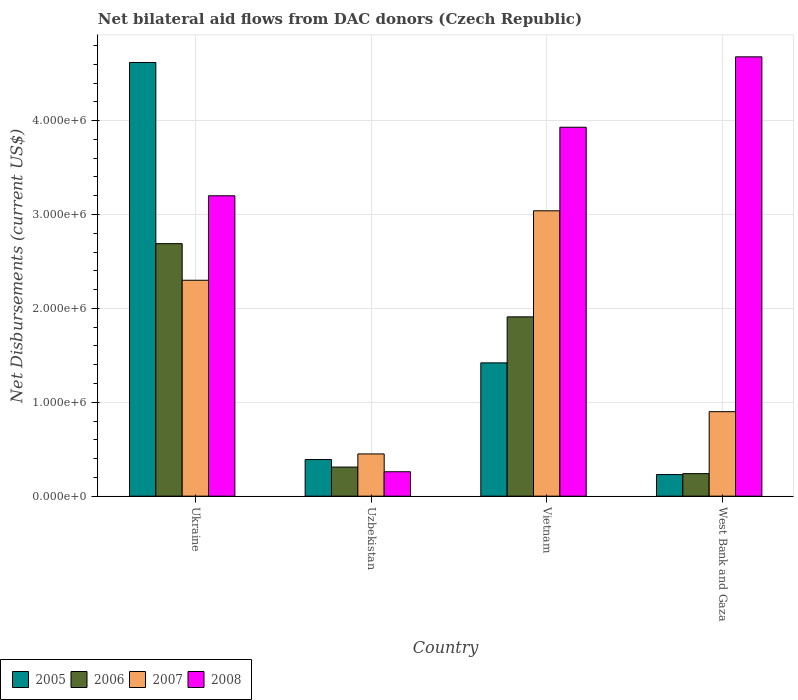How many groups of bars are there?
Your response must be concise. 4. Are the number of bars per tick equal to the number of legend labels?
Your answer should be compact. Yes. Are the number of bars on each tick of the X-axis equal?
Your response must be concise. Yes. What is the label of the 2nd group of bars from the left?
Keep it short and to the point. Uzbekistan. What is the net bilateral aid flows in 2006 in Uzbekistan?
Offer a very short reply. 3.10e+05. Across all countries, what is the maximum net bilateral aid flows in 2007?
Offer a terse response. 3.04e+06. Across all countries, what is the minimum net bilateral aid flows in 2008?
Keep it short and to the point. 2.60e+05. In which country was the net bilateral aid flows in 2008 maximum?
Provide a short and direct response. West Bank and Gaza. In which country was the net bilateral aid flows in 2007 minimum?
Make the answer very short. Uzbekistan. What is the total net bilateral aid flows in 2007 in the graph?
Give a very brief answer. 6.69e+06. What is the difference between the net bilateral aid flows in 2005 in Ukraine and that in Vietnam?
Keep it short and to the point. 3.20e+06. What is the difference between the net bilateral aid flows in 2007 in Vietnam and the net bilateral aid flows in 2006 in Uzbekistan?
Give a very brief answer. 2.73e+06. What is the average net bilateral aid flows in 2006 per country?
Keep it short and to the point. 1.29e+06. What is the difference between the net bilateral aid flows of/in 2007 and net bilateral aid flows of/in 2006 in Ukraine?
Make the answer very short. -3.90e+05. In how many countries, is the net bilateral aid flows in 2008 greater than 3000000 US$?
Provide a short and direct response. 3. What is the ratio of the net bilateral aid flows in 2006 in Uzbekistan to that in Vietnam?
Ensure brevity in your answer.  0.16. Is the net bilateral aid flows in 2005 in Ukraine less than that in West Bank and Gaza?
Your response must be concise. No. What is the difference between the highest and the second highest net bilateral aid flows in 2008?
Your answer should be very brief. 1.48e+06. What is the difference between the highest and the lowest net bilateral aid flows in 2005?
Your answer should be compact. 4.39e+06. In how many countries, is the net bilateral aid flows in 2007 greater than the average net bilateral aid flows in 2007 taken over all countries?
Provide a short and direct response. 2. Is it the case that in every country, the sum of the net bilateral aid flows in 2005 and net bilateral aid flows in 2008 is greater than the sum of net bilateral aid flows in 2007 and net bilateral aid flows in 2006?
Your answer should be very brief. No. What does the 3rd bar from the left in Uzbekistan represents?
Offer a terse response. 2007. Are all the bars in the graph horizontal?
Provide a short and direct response. No. How many countries are there in the graph?
Offer a terse response. 4. What is the difference between two consecutive major ticks on the Y-axis?
Provide a short and direct response. 1.00e+06. Does the graph contain any zero values?
Make the answer very short. No. Does the graph contain grids?
Provide a succinct answer. Yes. Where does the legend appear in the graph?
Give a very brief answer. Bottom left. How are the legend labels stacked?
Offer a very short reply. Horizontal. What is the title of the graph?
Your response must be concise. Net bilateral aid flows from DAC donors (Czech Republic). What is the label or title of the Y-axis?
Keep it short and to the point. Net Disbursements (current US$). What is the Net Disbursements (current US$) in 2005 in Ukraine?
Ensure brevity in your answer.  4.62e+06. What is the Net Disbursements (current US$) of 2006 in Ukraine?
Keep it short and to the point. 2.69e+06. What is the Net Disbursements (current US$) in 2007 in Ukraine?
Offer a very short reply. 2.30e+06. What is the Net Disbursements (current US$) in 2008 in Ukraine?
Keep it short and to the point. 3.20e+06. What is the Net Disbursements (current US$) of 2006 in Uzbekistan?
Your response must be concise. 3.10e+05. What is the Net Disbursements (current US$) in 2005 in Vietnam?
Your response must be concise. 1.42e+06. What is the Net Disbursements (current US$) of 2006 in Vietnam?
Offer a very short reply. 1.91e+06. What is the Net Disbursements (current US$) in 2007 in Vietnam?
Provide a short and direct response. 3.04e+06. What is the Net Disbursements (current US$) in 2008 in Vietnam?
Your answer should be compact. 3.93e+06. What is the Net Disbursements (current US$) in 2008 in West Bank and Gaza?
Offer a very short reply. 4.68e+06. Across all countries, what is the maximum Net Disbursements (current US$) in 2005?
Offer a terse response. 4.62e+06. Across all countries, what is the maximum Net Disbursements (current US$) of 2006?
Your response must be concise. 2.69e+06. Across all countries, what is the maximum Net Disbursements (current US$) of 2007?
Provide a succinct answer. 3.04e+06. Across all countries, what is the maximum Net Disbursements (current US$) of 2008?
Offer a very short reply. 4.68e+06. Across all countries, what is the minimum Net Disbursements (current US$) in 2005?
Provide a short and direct response. 2.30e+05. What is the total Net Disbursements (current US$) in 2005 in the graph?
Provide a succinct answer. 6.66e+06. What is the total Net Disbursements (current US$) of 2006 in the graph?
Offer a terse response. 5.15e+06. What is the total Net Disbursements (current US$) of 2007 in the graph?
Your answer should be compact. 6.69e+06. What is the total Net Disbursements (current US$) in 2008 in the graph?
Your answer should be compact. 1.21e+07. What is the difference between the Net Disbursements (current US$) of 2005 in Ukraine and that in Uzbekistan?
Ensure brevity in your answer.  4.23e+06. What is the difference between the Net Disbursements (current US$) of 2006 in Ukraine and that in Uzbekistan?
Give a very brief answer. 2.38e+06. What is the difference between the Net Disbursements (current US$) of 2007 in Ukraine and that in Uzbekistan?
Provide a short and direct response. 1.85e+06. What is the difference between the Net Disbursements (current US$) in 2008 in Ukraine and that in Uzbekistan?
Provide a short and direct response. 2.94e+06. What is the difference between the Net Disbursements (current US$) of 2005 in Ukraine and that in Vietnam?
Your response must be concise. 3.20e+06. What is the difference between the Net Disbursements (current US$) of 2006 in Ukraine and that in Vietnam?
Ensure brevity in your answer.  7.80e+05. What is the difference between the Net Disbursements (current US$) in 2007 in Ukraine and that in Vietnam?
Keep it short and to the point. -7.40e+05. What is the difference between the Net Disbursements (current US$) in 2008 in Ukraine and that in Vietnam?
Make the answer very short. -7.30e+05. What is the difference between the Net Disbursements (current US$) of 2005 in Ukraine and that in West Bank and Gaza?
Your answer should be compact. 4.39e+06. What is the difference between the Net Disbursements (current US$) in 2006 in Ukraine and that in West Bank and Gaza?
Keep it short and to the point. 2.45e+06. What is the difference between the Net Disbursements (current US$) in 2007 in Ukraine and that in West Bank and Gaza?
Make the answer very short. 1.40e+06. What is the difference between the Net Disbursements (current US$) in 2008 in Ukraine and that in West Bank and Gaza?
Offer a very short reply. -1.48e+06. What is the difference between the Net Disbursements (current US$) of 2005 in Uzbekistan and that in Vietnam?
Your answer should be compact. -1.03e+06. What is the difference between the Net Disbursements (current US$) of 2006 in Uzbekistan and that in Vietnam?
Offer a very short reply. -1.60e+06. What is the difference between the Net Disbursements (current US$) in 2007 in Uzbekistan and that in Vietnam?
Give a very brief answer. -2.59e+06. What is the difference between the Net Disbursements (current US$) of 2008 in Uzbekistan and that in Vietnam?
Give a very brief answer. -3.67e+06. What is the difference between the Net Disbursements (current US$) of 2005 in Uzbekistan and that in West Bank and Gaza?
Offer a terse response. 1.60e+05. What is the difference between the Net Disbursements (current US$) in 2006 in Uzbekistan and that in West Bank and Gaza?
Provide a succinct answer. 7.00e+04. What is the difference between the Net Disbursements (current US$) of 2007 in Uzbekistan and that in West Bank and Gaza?
Your response must be concise. -4.50e+05. What is the difference between the Net Disbursements (current US$) in 2008 in Uzbekistan and that in West Bank and Gaza?
Offer a very short reply. -4.42e+06. What is the difference between the Net Disbursements (current US$) of 2005 in Vietnam and that in West Bank and Gaza?
Offer a terse response. 1.19e+06. What is the difference between the Net Disbursements (current US$) in 2006 in Vietnam and that in West Bank and Gaza?
Offer a very short reply. 1.67e+06. What is the difference between the Net Disbursements (current US$) in 2007 in Vietnam and that in West Bank and Gaza?
Ensure brevity in your answer.  2.14e+06. What is the difference between the Net Disbursements (current US$) of 2008 in Vietnam and that in West Bank and Gaza?
Keep it short and to the point. -7.50e+05. What is the difference between the Net Disbursements (current US$) of 2005 in Ukraine and the Net Disbursements (current US$) of 2006 in Uzbekistan?
Give a very brief answer. 4.31e+06. What is the difference between the Net Disbursements (current US$) of 2005 in Ukraine and the Net Disbursements (current US$) of 2007 in Uzbekistan?
Ensure brevity in your answer.  4.17e+06. What is the difference between the Net Disbursements (current US$) of 2005 in Ukraine and the Net Disbursements (current US$) of 2008 in Uzbekistan?
Offer a very short reply. 4.36e+06. What is the difference between the Net Disbursements (current US$) in 2006 in Ukraine and the Net Disbursements (current US$) in 2007 in Uzbekistan?
Your answer should be very brief. 2.24e+06. What is the difference between the Net Disbursements (current US$) in 2006 in Ukraine and the Net Disbursements (current US$) in 2008 in Uzbekistan?
Offer a terse response. 2.43e+06. What is the difference between the Net Disbursements (current US$) in 2007 in Ukraine and the Net Disbursements (current US$) in 2008 in Uzbekistan?
Offer a terse response. 2.04e+06. What is the difference between the Net Disbursements (current US$) of 2005 in Ukraine and the Net Disbursements (current US$) of 2006 in Vietnam?
Keep it short and to the point. 2.71e+06. What is the difference between the Net Disbursements (current US$) in 2005 in Ukraine and the Net Disbursements (current US$) in 2007 in Vietnam?
Offer a terse response. 1.58e+06. What is the difference between the Net Disbursements (current US$) in 2005 in Ukraine and the Net Disbursements (current US$) in 2008 in Vietnam?
Your answer should be very brief. 6.90e+05. What is the difference between the Net Disbursements (current US$) in 2006 in Ukraine and the Net Disbursements (current US$) in 2007 in Vietnam?
Provide a short and direct response. -3.50e+05. What is the difference between the Net Disbursements (current US$) of 2006 in Ukraine and the Net Disbursements (current US$) of 2008 in Vietnam?
Provide a short and direct response. -1.24e+06. What is the difference between the Net Disbursements (current US$) in 2007 in Ukraine and the Net Disbursements (current US$) in 2008 in Vietnam?
Your response must be concise. -1.63e+06. What is the difference between the Net Disbursements (current US$) in 2005 in Ukraine and the Net Disbursements (current US$) in 2006 in West Bank and Gaza?
Ensure brevity in your answer.  4.38e+06. What is the difference between the Net Disbursements (current US$) of 2005 in Ukraine and the Net Disbursements (current US$) of 2007 in West Bank and Gaza?
Your answer should be very brief. 3.72e+06. What is the difference between the Net Disbursements (current US$) of 2006 in Ukraine and the Net Disbursements (current US$) of 2007 in West Bank and Gaza?
Give a very brief answer. 1.79e+06. What is the difference between the Net Disbursements (current US$) in 2006 in Ukraine and the Net Disbursements (current US$) in 2008 in West Bank and Gaza?
Provide a short and direct response. -1.99e+06. What is the difference between the Net Disbursements (current US$) in 2007 in Ukraine and the Net Disbursements (current US$) in 2008 in West Bank and Gaza?
Your answer should be very brief. -2.38e+06. What is the difference between the Net Disbursements (current US$) in 2005 in Uzbekistan and the Net Disbursements (current US$) in 2006 in Vietnam?
Provide a short and direct response. -1.52e+06. What is the difference between the Net Disbursements (current US$) of 2005 in Uzbekistan and the Net Disbursements (current US$) of 2007 in Vietnam?
Provide a short and direct response. -2.65e+06. What is the difference between the Net Disbursements (current US$) in 2005 in Uzbekistan and the Net Disbursements (current US$) in 2008 in Vietnam?
Provide a short and direct response. -3.54e+06. What is the difference between the Net Disbursements (current US$) of 2006 in Uzbekistan and the Net Disbursements (current US$) of 2007 in Vietnam?
Your answer should be very brief. -2.73e+06. What is the difference between the Net Disbursements (current US$) of 2006 in Uzbekistan and the Net Disbursements (current US$) of 2008 in Vietnam?
Your response must be concise. -3.62e+06. What is the difference between the Net Disbursements (current US$) of 2007 in Uzbekistan and the Net Disbursements (current US$) of 2008 in Vietnam?
Provide a succinct answer. -3.48e+06. What is the difference between the Net Disbursements (current US$) of 2005 in Uzbekistan and the Net Disbursements (current US$) of 2007 in West Bank and Gaza?
Offer a very short reply. -5.10e+05. What is the difference between the Net Disbursements (current US$) in 2005 in Uzbekistan and the Net Disbursements (current US$) in 2008 in West Bank and Gaza?
Give a very brief answer. -4.29e+06. What is the difference between the Net Disbursements (current US$) in 2006 in Uzbekistan and the Net Disbursements (current US$) in 2007 in West Bank and Gaza?
Ensure brevity in your answer.  -5.90e+05. What is the difference between the Net Disbursements (current US$) in 2006 in Uzbekistan and the Net Disbursements (current US$) in 2008 in West Bank and Gaza?
Offer a terse response. -4.37e+06. What is the difference between the Net Disbursements (current US$) in 2007 in Uzbekistan and the Net Disbursements (current US$) in 2008 in West Bank and Gaza?
Provide a short and direct response. -4.23e+06. What is the difference between the Net Disbursements (current US$) of 2005 in Vietnam and the Net Disbursements (current US$) of 2006 in West Bank and Gaza?
Your answer should be compact. 1.18e+06. What is the difference between the Net Disbursements (current US$) of 2005 in Vietnam and the Net Disbursements (current US$) of 2007 in West Bank and Gaza?
Offer a very short reply. 5.20e+05. What is the difference between the Net Disbursements (current US$) in 2005 in Vietnam and the Net Disbursements (current US$) in 2008 in West Bank and Gaza?
Give a very brief answer. -3.26e+06. What is the difference between the Net Disbursements (current US$) in 2006 in Vietnam and the Net Disbursements (current US$) in 2007 in West Bank and Gaza?
Give a very brief answer. 1.01e+06. What is the difference between the Net Disbursements (current US$) of 2006 in Vietnam and the Net Disbursements (current US$) of 2008 in West Bank and Gaza?
Your answer should be compact. -2.77e+06. What is the difference between the Net Disbursements (current US$) of 2007 in Vietnam and the Net Disbursements (current US$) of 2008 in West Bank and Gaza?
Your answer should be very brief. -1.64e+06. What is the average Net Disbursements (current US$) in 2005 per country?
Give a very brief answer. 1.66e+06. What is the average Net Disbursements (current US$) in 2006 per country?
Provide a short and direct response. 1.29e+06. What is the average Net Disbursements (current US$) of 2007 per country?
Provide a short and direct response. 1.67e+06. What is the average Net Disbursements (current US$) in 2008 per country?
Give a very brief answer. 3.02e+06. What is the difference between the Net Disbursements (current US$) of 2005 and Net Disbursements (current US$) of 2006 in Ukraine?
Your answer should be compact. 1.93e+06. What is the difference between the Net Disbursements (current US$) in 2005 and Net Disbursements (current US$) in 2007 in Ukraine?
Provide a short and direct response. 2.32e+06. What is the difference between the Net Disbursements (current US$) of 2005 and Net Disbursements (current US$) of 2008 in Ukraine?
Your answer should be very brief. 1.42e+06. What is the difference between the Net Disbursements (current US$) in 2006 and Net Disbursements (current US$) in 2007 in Ukraine?
Offer a very short reply. 3.90e+05. What is the difference between the Net Disbursements (current US$) in 2006 and Net Disbursements (current US$) in 2008 in Ukraine?
Ensure brevity in your answer.  -5.10e+05. What is the difference between the Net Disbursements (current US$) of 2007 and Net Disbursements (current US$) of 2008 in Ukraine?
Provide a short and direct response. -9.00e+05. What is the difference between the Net Disbursements (current US$) in 2005 and Net Disbursements (current US$) in 2006 in Uzbekistan?
Offer a terse response. 8.00e+04. What is the difference between the Net Disbursements (current US$) in 2005 and Net Disbursements (current US$) in 2008 in Uzbekistan?
Your response must be concise. 1.30e+05. What is the difference between the Net Disbursements (current US$) of 2006 and Net Disbursements (current US$) of 2007 in Uzbekistan?
Make the answer very short. -1.40e+05. What is the difference between the Net Disbursements (current US$) in 2006 and Net Disbursements (current US$) in 2008 in Uzbekistan?
Your response must be concise. 5.00e+04. What is the difference between the Net Disbursements (current US$) of 2007 and Net Disbursements (current US$) of 2008 in Uzbekistan?
Your response must be concise. 1.90e+05. What is the difference between the Net Disbursements (current US$) of 2005 and Net Disbursements (current US$) of 2006 in Vietnam?
Your answer should be compact. -4.90e+05. What is the difference between the Net Disbursements (current US$) of 2005 and Net Disbursements (current US$) of 2007 in Vietnam?
Offer a terse response. -1.62e+06. What is the difference between the Net Disbursements (current US$) in 2005 and Net Disbursements (current US$) in 2008 in Vietnam?
Make the answer very short. -2.51e+06. What is the difference between the Net Disbursements (current US$) of 2006 and Net Disbursements (current US$) of 2007 in Vietnam?
Keep it short and to the point. -1.13e+06. What is the difference between the Net Disbursements (current US$) in 2006 and Net Disbursements (current US$) in 2008 in Vietnam?
Offer a very short reply. -2.02e+06. What is the difference between the Net Disbursements (current US$) in 2007 and Net Disbursements (current US$) in 2008 in Vietnam?
Give a very brief answer. -8.90e+05. What is the difference between the Net Disbursements (current US$) in 2005 and Net Disbursements (current US$) in 2007 in West Bank and Gaza?
Make the answer very short. -6.70e+05. What is the difference between the Net Disbursements (current US$) of 2005 and Net Disbursements (current US$) of 2008 in West Bank and Gaza?
Keep it short and to the point. -4.45e+06. What is the difference between the Net Disbursements (current US$) in 2006 and Net Disbursements (current US$) in 2007 in West Bank and Gaza?
Offer a very short reply. -6.60e+05. What is the difference between the Net Disbursements (current US$) in 2006 and Net Disbursements (current US$) in 2008 in West Bank and Gaza?
Provide a succinct answer. -4.44e+06. What is the difference between the Net Disbursements (current US$) of 2007 and Net Disbursements (current US$) of 2008 in West Bank and Gaza?
Provide a short and direct response. -3.78e+06. What is the ratio of the Net Disbursements (current US$) of 2005 in Ukraine to that in Uzbekistan?
Your response must be concise. 11.85. What is the ratio of the Net Disbursements (current US$) of 2006 in Ukraine to that in Uzbekistan?
Your answer should be compact. 8.68. What is the ratio of the Net Disbursements (current US$) of 2007 in Ukraine to that in Uzbekistan?
Ensure brevity in your answer.  5.11. What is the ratio of the Net Disbursements (current US$) of 2008 in Ukraine to that in Uzbekistan?
Your answer should be very brief. 12.31. What is the ratio of the Net Disbursements (current US$) of 2005 in Ukraine to that in Vietnam?
Provide a short and direct response. 3.25. What is the ratio of the Net Disbursements (current US$) in 2006 in Ukraine to that in Vietnam?
Offer a terse response. 1.41. What is the ratio of the Net Disbursements (current US$) in 2007 in Ukraine to that in Vietnam?
Offer a terse response. 0.76. What is the ratio of the Net Disbursements (current US$) of 2008 in Ukraine to that in Vietnam?
Provide a short and direct response. 0.81. What is the ratio of the Net Disbursements (current US$) of 2005 in Ukraine to that in West Bank and Gaza?
Give a very brief answer. 20.09. What is the ratio of the Net Disbursements (current US$) of 2006 in Ukraine to that in West Bank and Gaza?
Keep it short and to the point. 11.21. What is the ratio of the Net Disbursements (current US$) in 2007 in Ukraine to that in West Bank and Gaza?
Offer a very short reply. 2.56. What is the ratio of the Net Disbursements (current US$) in 2008 in Ukraine to that in West Bank and Gaza?
Provide a succinct answer. 0.68. What is the ratio of the Net Disbursements (current US$) of 2005 in Uzbekistan to that in Vietnam?
Give a very brief answer. 0.27. What is the ratio of the Net Disbursements (current US$) of 2006 in Uzbekistan to that in Vietnam?
Offer a terse response. 0.16. What is the ratio of the Net Disbursements (current US$) in 2007 in Uzbekistan to that in Vietnam?
Give a very brief answer. 0.15. What is the ratio of the Net Disbursements (current US$) in 2008 in Uzbekistan to that in Vietnam?
Keep it short and to the point. 0.07. What is the ratio of the Net Disbursements (current US$) of 2005 in Uzbekistan to that in West Bank and Gaza?
Give a very brief answer. 1.7. What is the ratio of the Net Disbursements (current US$) in 2006 in Uzbekistan to that in West Bank and Gaza?
Make the answer very short. 1.29. What is the ratio of the Net Disbursements (current US$) in 2007 in Uzbekistan to that in West Bank and Gaza?
Make the answer very short. 0.5. What is the ratio of the Net Disbursements (current US$) of 2008 in Uzbekistan to that in West Bank and Gaza?
Provide a succinct answer. 0.06. What is the ratio of the Net Disbursements (current US$) of 2005 in Vietnam to that in West Bank and Gaza?
Your answer should be compact. 6.17. What is the ratio of the Net Disbursements (current US$) in 2006 in Vietnam to that in West Bank and Gaza?
Provide a short and direct response. 7.96. What is the ratio of the Net Disbursements (current US$) in 2007 in Vietnam to that in West Bank and Gaza?
Your response must be concise. 3.38. What is the ratio of the Net Disbursements (current US$) of 2008 in Vietnam to that in West Bank and Gaza?
Keep it short and to the point. 0.84. What is the difference between the highest and the second highest Net Disbursements (current US$) of 2005?
Provide a succinct answer. 3.20e+06. What is the difference between the highest and the second highest Net Disbursements (current US$) of 2006?
Ensure brevity in your answer.  7.80e+05. What is the difference between the highest and the second highest Net Disbursements (current US$) of 2007?
Your answer should be very brief. 7.40e+05. What is the difference between the highest and the second highest Net Disbursements (current US$) of 2008?
Provide a succinct answer. 7.50e+05. What is the difference between the highest and the lowest Net Disbursements (current US$) in 2005?
Offer a terse response. 4.39e+06. What is the difference between the highest and the lowest Net Disbursements (current US$) of 2006?
Your answer should be very brief. 2.45e+06. What is the difference between the highest and the lowest Net Disbursements (current US$) in 2007?
Keep it short and to the point. 2.59e+06. What is the difference between the highest and the lowest Net Disbursements (current US$) in 2008?
Ensure brevity in your answer.  4.42e+06. 